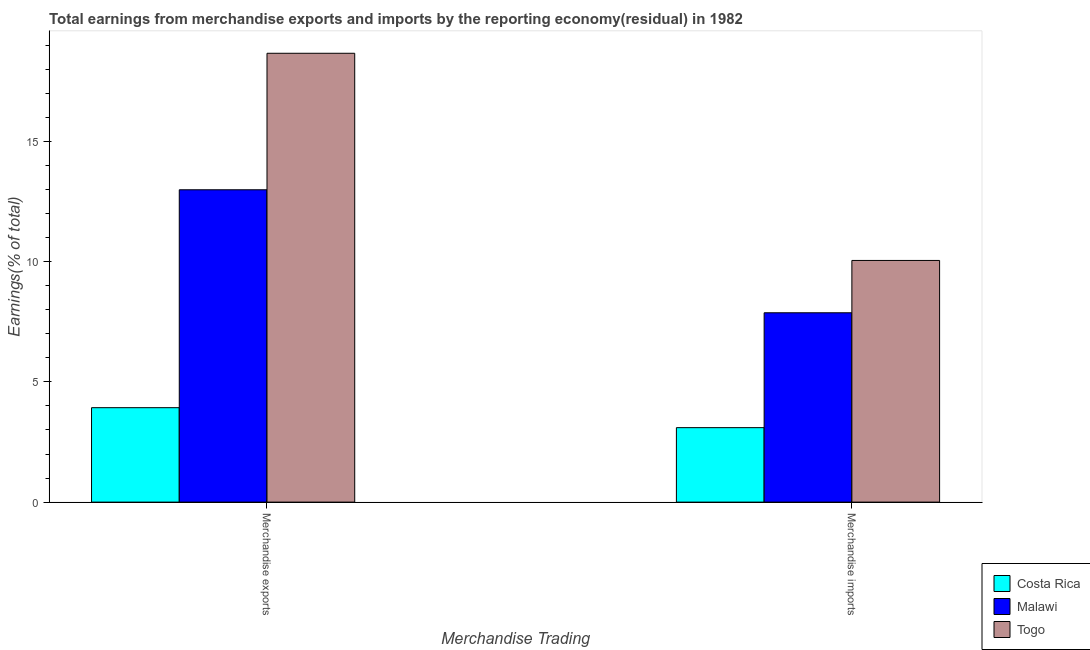How many different coloured bars are there?
Your answer should be very brief. 3. How many groups of bars are there?
Give a very brief answer. 2. How many bars are there on the 1st tick from the left?
Give a very brief answer. 3. What is the earnings from merchandise exports in Costa Rica?
Your response must be concise. 3.93. Across all countries, what is the maximum earnings from merchandise exports?
Your answer should be compact. 18.66. Across all countries, what is the minimum earnings from merchandise exports?
Ensure brevity in your answer.  3.93. In which country was the earnings from merchandise imports maximum?
Ensure brevity in your answer.  Togo. In which country was the earnings from merchandise imports minimum?
Offer a terse response. Costa Rica. What is the total earnings from merchandise imports in the graph?
Give a very brief answer. 21.02. What is the difference between the earnings from merchandise exports in Costa Rica and that in Togo?
Provide a short and direct response. -14.73. What is the difference between the earnings from merchandise imports in Togo and the earnings from merchandise exports in Malawi?
Give a very brief answer. -2.94. What is the average earnings from merchandise imports per country?
Offer a very short reply. 7.01. What is the difference between the earnings from merchandise imports and earnings from merchandise exports in Togo?
Ensure brevity in your answer.  -8.61. In how many countries, is the earnings from merchandise imports greater than 11 %?
Ensure brevity in your answer.  0. What is the ratio of the earnings from merchandise imports in Togo to that in Costa Rica?
Offer a very short reply. 3.25. In how many countries, is the earnings from merchandise imports greater than the average earnings from merchandise imports taken over all countries?
Keep it short and to the point. 2. What does the 3rd bar from the left in Merchandise exports represents?
Offer a terse response. Togo. What does the 3rd bar from the right in Merchandise imports represents?
Make the answer very short. Costa Rica. Are all the bars in the graph horizontal?
Offer a very short reply. No. How many countries are there in the graph?
Give a very brief answer. 3. What is the difference between two consecutive major ticks on the Y-axis?
Offer a very short reply. 5. Are the values on the major ticks of Y-axis written in scientific E-notation?
Provide a succinct answer. No. Does the graph contain any zero values?
Ensure brevity in your answer.  No. Does the graph contain grids?
Your answer should be compact. No. How many legend labels are there?
Offer a very short reply. 3. What is the title of the graph?
Provide a short and direct response. Total earnings from merchandise exports and imports by the reporting economy(residual) in 1982. What is the label or title of the X-axis?
Offer a terse response. Merchandise Trading. What is the label or title of the Y-axis?
Provide a short and direct response. Earnings(% of total). What is the Earnings(% of total) of Costa Rica in Merchandise exports?
Your answer should be very brief. 3.93. What is the Earnings(% of total) of Malawi in Merchandise exports?
Offer a terse response. 12.99. What is the Earnings(% of total) of Togo in Merchandise exports?
Ensure brevity in your answer.  18.66. What is the Earnings(% of total) in Costa Rica in Merchandise imports?
Your answer should be very brief. 3.1. What is the Earnings(% of total) in Malawi in Merchandise imports?
Make the answer very short. 7.87. What is the Earnings(% of total) of Togo in Merchandise imports?
Your answer should be very brief. 10.05. Across all Merchandise Trading, what is the maximum Earnings(% of total) of Costa Rica?
Ensure brevity in your answer.  3.93. Across all Merchandise Trading, what is the maximum Earnings(% of total) in Malawi?
Provide a succinct answer. 12.99. Across all Merchandise Trading, what is the maximum Earnings(% of total) of Togo?
Provide a short and direct response. 18.66. Across all Merchandise Trading, what is the minimum Earnings(% of total) in Costa Rica?
Keep it short and to the point. 3.1. Across all Merchandise Trading, what is the minimum Earnings(% of total) of Malawi?
Keep it short and to the point. 7.87. Across all Merchandise Trading, what is the minimum Earnings(% of total) of Togo?
Offer a very short reply. 10.05. What is the total Earnings(% of total) in Costa Rica in the graph?
Provide a succinct answer. 7.02. What is the total Earnings(% of total) in Malawi in the graph?
Your answer should be compact. 20.86. What is the total Earnings(% of total) of Togo in the graph?
Provide a short and direct response. 28.71. What is the difference between the Earnings(% of total) in Costa Rica in Merchandise exports and that in Merchandise imports?
Give a very brief answer. 0.83. What is the difference between the Earnings(% of total) in Malawi in Merchandise exports and that in Merchandise imports?
Your answer should be compact. 5.11. What is the difference between the Earnings(% of total) of Togo in Merchandise exports and that in Merchandise imports?
Keep it short and to the point. 8.61. What is the difference between the Earnings(% of total) of Costa Rica in Merchandise exports and the Earnings(% of total) of Malawi in Merchandise imports?
Keep it short and to the point. -3.95. What is the difference between the Earnings(% of total) in Costa Rica in Merchandise exports and the Earnings(% of total) in Togo in Merchandise imports?
Your response must be concise. -6.12. What is the difference between the Earnings(% of total) of Malawi in Merchandise exports and the Earnings(% of total) of Togo in Merchandise imports?
Ensure brevity in your answer.  2.94. What is the average Earnings(% of total) of Costa Rica per Merchandise Trading?
Keep it short and to the point. 3.51. What is the average Earnings(% of total) in Malawi per Merchandise Trading?
Provide a succinct answer. 10.43. What is the average Earnings(% of total) in Togo per Merchandise Trading?
Make the answer very short. 14.35. What is the difference between the Earnings(% of total) of Costa Rica and Earnings(% of total) of Malawi in Merchandise exports?
Your answer should be very brief. -9.06. What is the difference between the Earnings(% of total) of Costa Rica and Earnings(% of total) of Togo in Merchandise exports?
Offer a very short reply. -14.73. What is the difference between the Earnings(% of total) of Malawi and Earnings(% of total) of Togo in Merchandise exports?
Keep it short and to the point. -5.68. What is the difference between the Earnings(% of total) of Costa Rica and Earnings(% of total) of Malawi in Merchandise imports?
Give a very brief answer. -4.78. What is the difference between the Earnings(% of total) of Costa Rica and Earnings(% of total) of Togo in Merchandise imports?
Your answer should be very brief. -6.95. What is the difference between the Earnings(% of total) in Malawi and Earnings(% of total) in Togo in Merchandise imports?
Your response must be concise. -2.17. What is the ratio of the Earnings(% of total) of Costa Rica in Merchandise exports to that in Merchandise imports?
Your answer should be compact. 1.27. What is the ratio of the Earnings(% of total) of Malawi in Merchandise exports to that in Merchandise imports?
Your answer should be very brief. 1.65. What is the ratio of the Earnings(% of total) in Togo in Merchandise exports to that in Merchandise imports?
Keep it short and to the point. 1.86. What is the difference between the highest and the second highest Earnings(% of total) of Costa Rica?
Your response must be concise. 0.83. What is the difference between the highest and the second highest Earnings(% of total) of Malawi?
Ensure brevity in your answer.  5.11. What is the difference between the highest and the second highest Earnings(% of total) of Togo?
Offer a terse response. 8.61. What is the difference between the highest and the lowest Earnings(% of total) of Costa Rica?
Your answer should be compact. 0.83. What is the difference between the highest and the lowest Earnings(% of total) in Malawi?
Give a very brief answer. 5.11. What is the difference between the highest and the lowest Earnings(% of total) in Togo?
Your answer should be very brief. 8.61. 